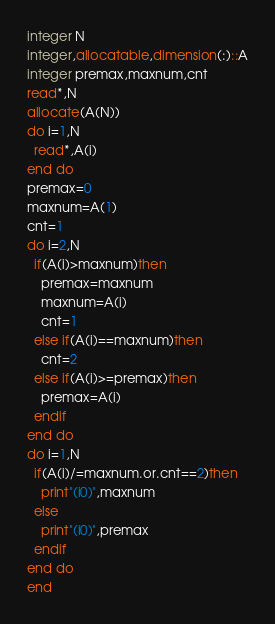Convert code to text. <code><loc_0><loc_0><loc_500><loc_500><_FORTRAN_>integer N
integer,allocatable,dimension(:)::A
integer premax,maxnum,cnt
read*,N
allocate(A(N))
do i=1,N
  read*,A(i)
end do
premax=0
maxnum=A(1)
cnt=1
do i=2,N
  if(A(i)>maxnum)then
    premax=maxnum
    maxnum=A(i)
    cnt=1
  else if(A(i)==maxnum)then
    cnt=2
  else if(A(i)>=premax)then
    premax=A(i)
  endif
end do
do i=1,N
  if(A(i)/=maxnum.or.cnt==2)then
    print"(i0)",maxnum
  else
    print"(i0)",premax
  endif
end do
end
</code> 